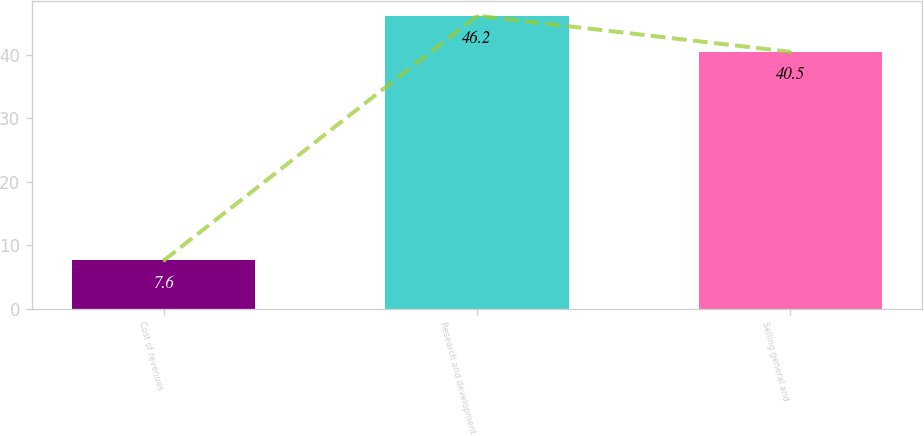Convert chart. <chart><loc_0><loc_0><loc_500><loc_500><bar_chart><fcel>Cost of revenues<fcel>Research and development<fcel>Selling general and<nl><fcel>7.6<fcel>46.2<fcel>40.5<nl></chart> 